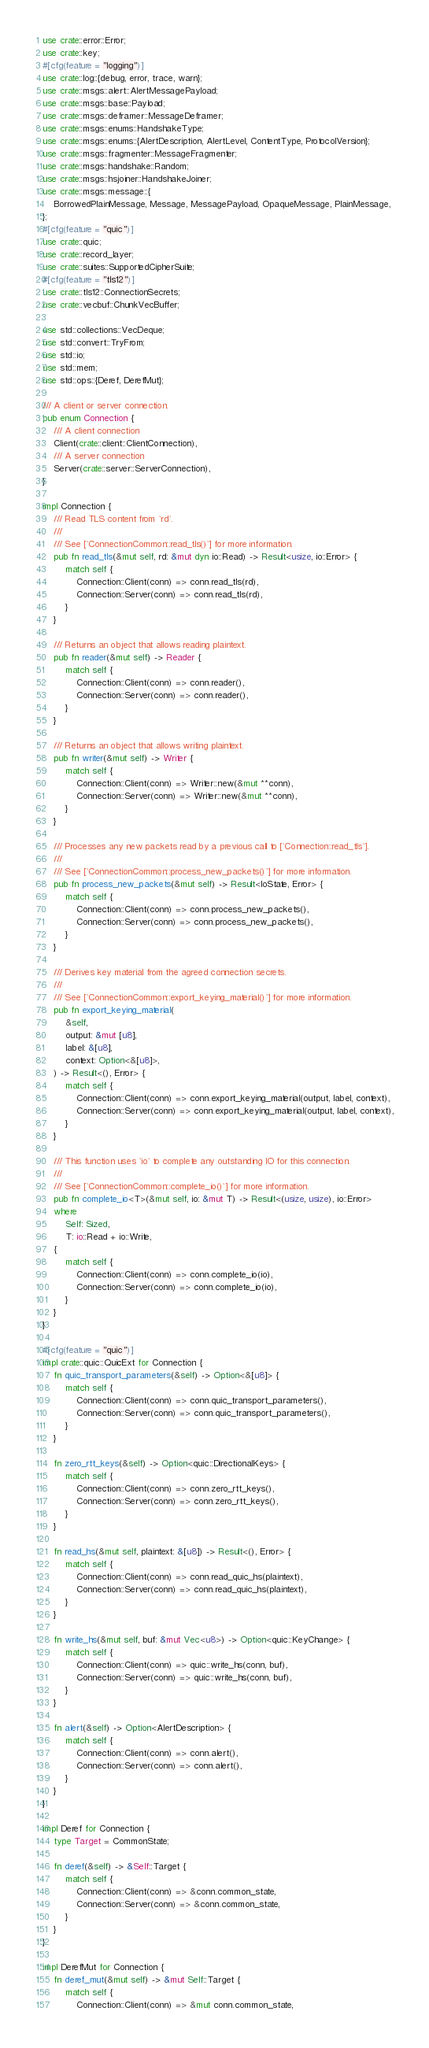<code> <loc_0><loc_0><loc_500><loc_500><_Rust_>use crate::error::Error;
use crate::key;
#[cfg(feature = "logging")]
use crate::log::{debug, error, trace, warn};
use crate::msgs::alert::AlertMessagePayload;
use crate::msgs::base::Payload;
use crate::msgs::deframer::MessageDeframer;
use crate::msgs::enums::HandshakeType;
use crate::msgs::enums::{AlertDescription, AlertLevel, ContentType, ProtocolVersion};
use crate::msgs::fragmenter::MessageFragmenter;
use crate::msgs::handshake::Random;
use crate::msgs::hsjoiner::HandshakeJoiner;
use crate::msgs::message::{
    BorrowedPlainMessage, Message, MessagePayload, OpaqueMessage, PlainMessage,
};
#[cfg(feature = "quic")]
use crate::quic;
use crate::record_layer;
use crate::suites::SupportedCipherSuite;
#[cfg(feature = "tls12")]
use crate::tls12::ConnectionSecrets;
use crate::vecbuf::ChunkVecBuffer;

use std::collections::VecDeque;
use std::convert::TryFrom;
use std::io;
use std::mem;
use std::ops::{Deref, DerefMut};

/// A client or server connection.
pub enum Connection {
    /// A client connection
    Client(crate::client::ClientConnection),
    /// A server connection
    Server(crate::server::ServerConnection),
}

impl Connection {
    /// Read TLS content from `rd`.
    ///
    /// See [`ConnectionCommon::read_tls()`] for more information.
    pub fn read_tls(&mut self, rd: &mut dyn io::Read) -> Result<usize, io::Error> {
        match self {
            Connection::Client(conn) => conn.read_tls(rd),
            Connection::Server(conn) => conn.read_tls(rd),
        }
    }

    /// Returns an object that allows reading plaintext.
    pub fn reader(&mut self) -> Reader {
        match self {
            Connection::Client(conn) => conn.reader(),
            Connection::Server(conn) => conn.reader(),
        }
    }

    /// Returns an object that allows writing plaintext.
    pub fn writer(&mut self) -> Writer {
        match self {
            Connection::Client(conn) => Writer::new(&mut **conn),
            Connection::Server(conn) => Writer::new(&mut **conn),
        }
    }

    /// Processes any new packets read by a previous call to [`Connection::read_tls`].
    ///
    /// See [`ConnectionCommon::process_new_packets()`] for more information.
    pub fn process_new_packets(&mut self) -> Result<IoState, Error> {
        match self {
            Connection::Client(conn) => conn.process_new_packets(),
            Connection::Server(conn) => conn.process_new_packets(),
        }
    }

    /// Derives key material from the agreed connection secrets.
    ///
    /// See [`ConnectionCommon::export_keying_material()`] for more information.
    pub fn export_keying_material(
        &self,
        output: &mut [u8],
        label: &[u8],
        context: Option<&[u8]>,
    ) -> Result<(), Error> {
        match self {
            Connection::Client(conn) => conn.export_keying_material(output, label, context),
            Connection::Server(conn) => conn.export_keying_material(output, label, context),
        }
    }

    /// This function uses `io` to complete any outstanding IO for this connection.
    ///
    /// See [`ConnectionCommon::complete_io()`] for more information.
    pub fn complete_io<T>(&mut self, io: &mut T) -> Result<(usize, usize), io::Error>
    where
        Self: Sized,
        T: io::Read + io::Write,
    {
        match self {
            Connection::Client(conn) => conn.complete_io(io),
            Connection::Server(conn) => conn.complete_io(io),
        }
    }
}

#[cfg(feature = "quic")]
impl crate::quic::QuicExt for Connection {
    fn quic_transport_parameters(&self) -> Option<&[u8]> {
        match self {
            Connection::Client(conn) => conn.quic_transport_parameters(),
            Connection::Server(conn) => conn.quic_transport_parameters(),
        }
    }

    fn zero_rtt_keys(&self) -> Option<quic::DirectionalKeys> {
        match self {
            Connection::Client(conn) => conn.zero_rtt_keys(),
            Connection::Server(conn) => conn.zero_rtt_keys(),
        }
    }

    fn read_hs(&mut self, plaintext: &[u8]) -> Result<(), Error> {
        match self {
            Connection::Client(conn) => conn.read_quic_hs(plaintext),
            Connection::Server(conn) => conn.read_quic_hs(plaintext),
        }
    }

    fn write_hs(&mut self, buf: &mut Vec<u8>) -> Option<quic::KeyChange> {
        match self {
            Connection::Client(conn) => quic::write_hs(conn, buf),
            Connection::Server(conn) => quic::write_hs(conn, buf),
        }
    }

    fn alert(&self) -> Option<AlertDescription> {
        match self {
            Connection::Client(conn) => conn.alert(),
            Connection::Server(conn) => conn.alert(),
        }
    }
}

impl Deref for Connection {
    type Target = CommonState;

    fn deref(&self) -> &Self::Target {
        match self {
            Connection::Client(conn) => &conn.common_state,
            Connection::Server(conn) => &conn.common_state,
        }
    }
}

impl DerefMut for Connection {
    fn deref_mut(&mut self) -> &mut Self::Target {
        match self {
            Connection::Client(conn) => &mut conn.common_state,</code> 